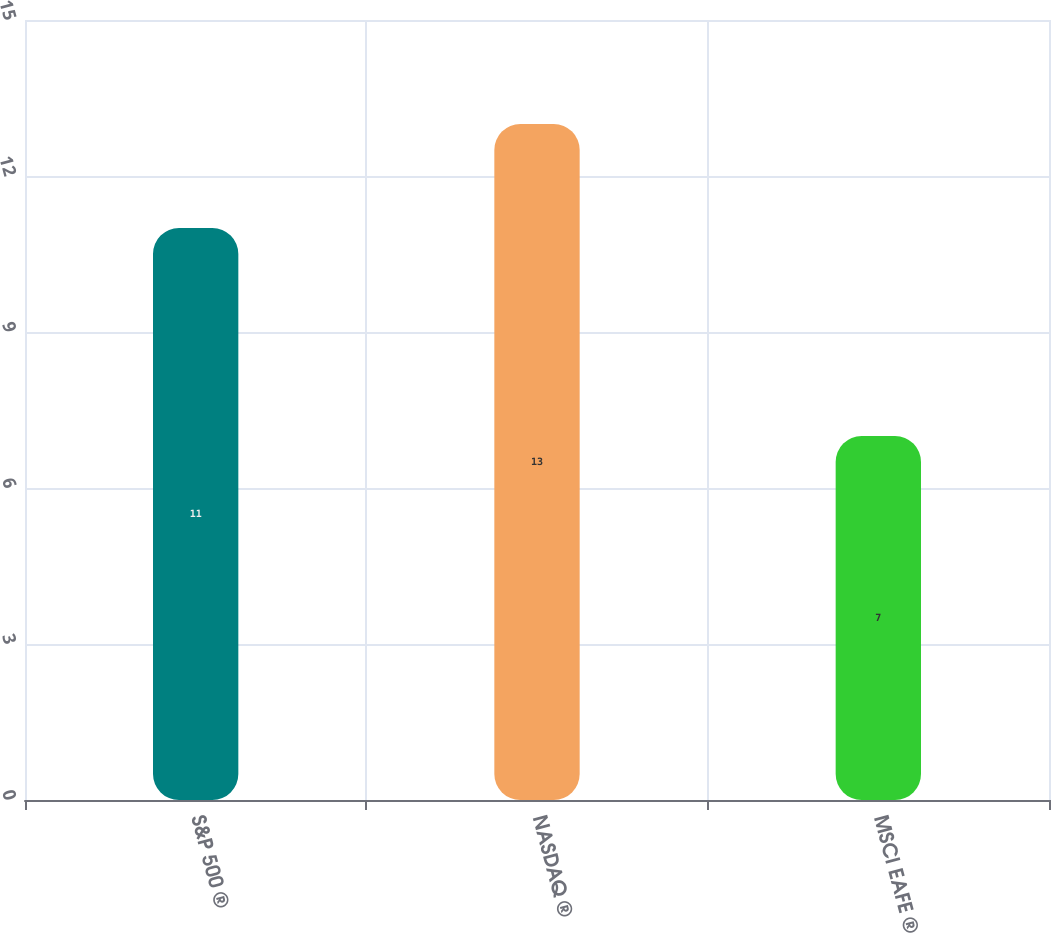Convert chart to OTSL. <chart><loc_0><loc_0><loc_500><loc_500><bar_chart><fcel>S&P 500 ®<fcel>NASDAQ ®<fcel>MSCI EAFE ®<nl><fcel>11<fcel>13<fcel>7<nl></chart> 